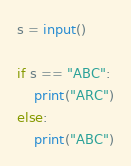Convert code to text. <code><loc_0><loc_0><loc_500><loc_500><_Python_>s = input()

if s == "ABC":
    print("ARC")
else:
    print("ABC")</code> 